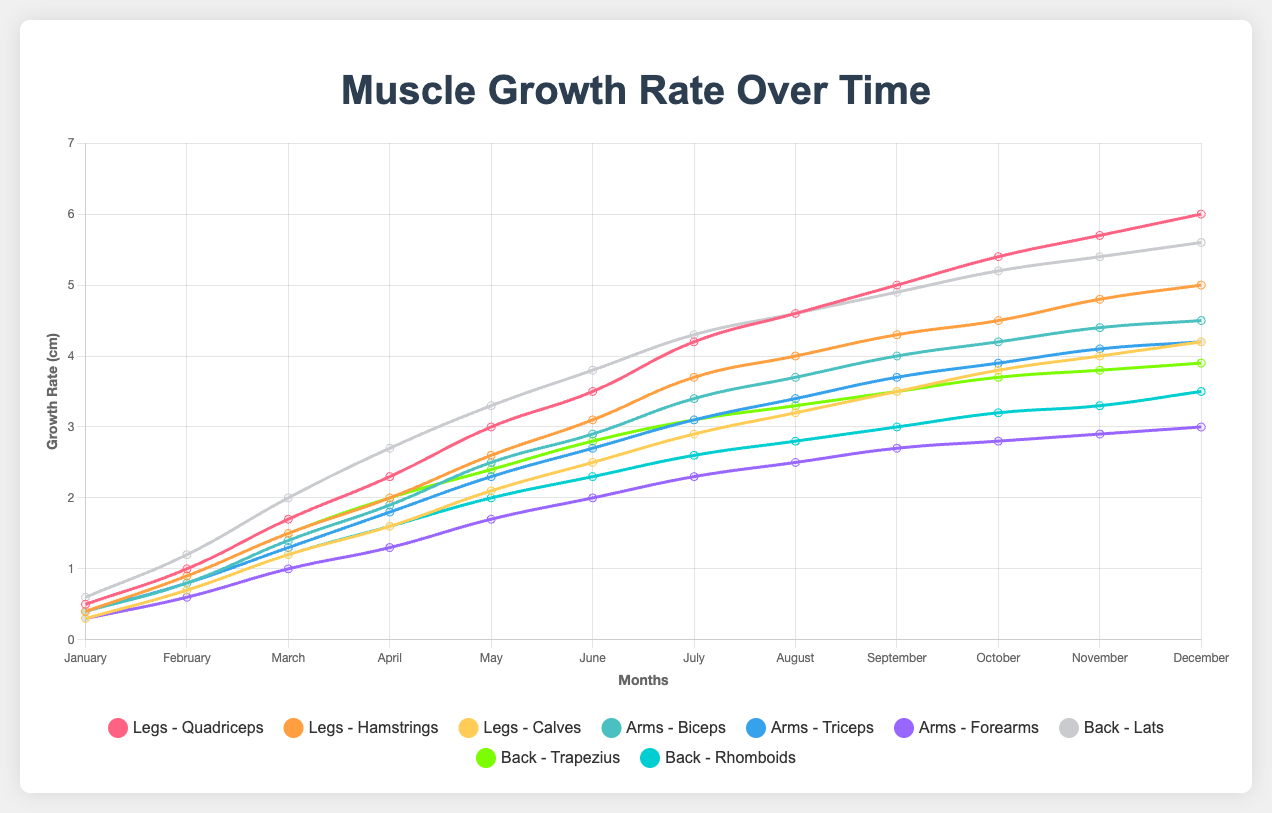Which muscle group experienced the highest growth in a single month? To determine the highest growth in a single month, we compare the growth rates for each muscle group month by month. The Quadriceps in the Legs group grew by 0.7 cm from March to April, which is the highest observed growth in one month.
Answer: Quadriceps (Legs), 0.7 cm from March to April Which muscle group had the highest overall growth from January to December? To find the highest overall growth, we look at the growth rate for each muscle group in December. The Quadriceps in the Legs group grew the most, reaching 6.0 cm by December.
Answer: Quadriceps (Legs), 6.0 cm What is the average growth rate of the Biceps throughout the year? To calculate the average growth rate, sum the monthly growth rates of the Biceps and divide by 12. (0.4 + 0.8 + 1.4 + 1.9 + 2.5 + 2.9 + 3.4 + 3.7 + 4.0 + 4.2 + 4.4 + 4.5) / 12 ≈ 2.68
Answer: ~2.68 cm Which month shows the peak difference in growth between Quadriceps and Hamstrings? To find the peak difference, calculate the monthly differences between Quadriceps and Hamstrings and find the maximum. The maximum difference is in December: Quadriceps (6.0) - Hamstrings (5.0) = 1.0 cm.
Answer: December, 1.0 cm Did any muscle group have consistent monthly growth without any decreases or plateaus? Check if any muscle group shows a steady increase each month without any month showing a decrease or no change. The Lats in the Back group consistently grow each month.
Answer: Lats (Back) How much did the growth rate of Calves change from January to December? Subtract the January value from the December value for Calves. 4.2 - 0.3 = 3.9 cm
Answer: 3.9 cm Which muscle group had the least variability in growth rates over the year? Calculate the range for each muscle group's growth rates by subtracting the minimum monthly growth rate from the maximum. The Rhomboids in the Back group had the smallest range: 3.5 - 0.3 = 3.2 cm
Answer: Rhomboids (Back), 3.2 cm In which month did the Lats experience the largest growth increment? Determine the month-to-month increments for the Lats and find the largest one. The largest increment is from February to March: 2.0 - 1.2 = 0.8 cm.
Answer: March, 0.8 cm Did the Forearms ever surpass the Biceps in growth rate during the year? Compare the monthly growth rates of Forearms and Biceps. Forearms never surpassed Biceps in any month.
Answer: No 